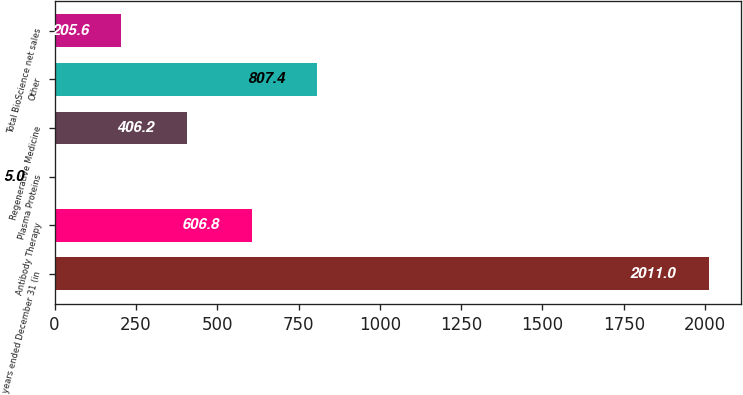<chart> <loc_0><loc_0><loc_500><loc_500><bar_chart><fcel>years ended December 31 (in<fcel>Antibody Therapy<fcel>Plasma Proteins<fcel>Regenerative Medicine<fcel>Other<fcel>Total BioScience net sales<nl><fcel>2011<fcel>606.8<fcel>5<fcel>406.2<fcel>807.4<fcel>205.6<nl></chart> 